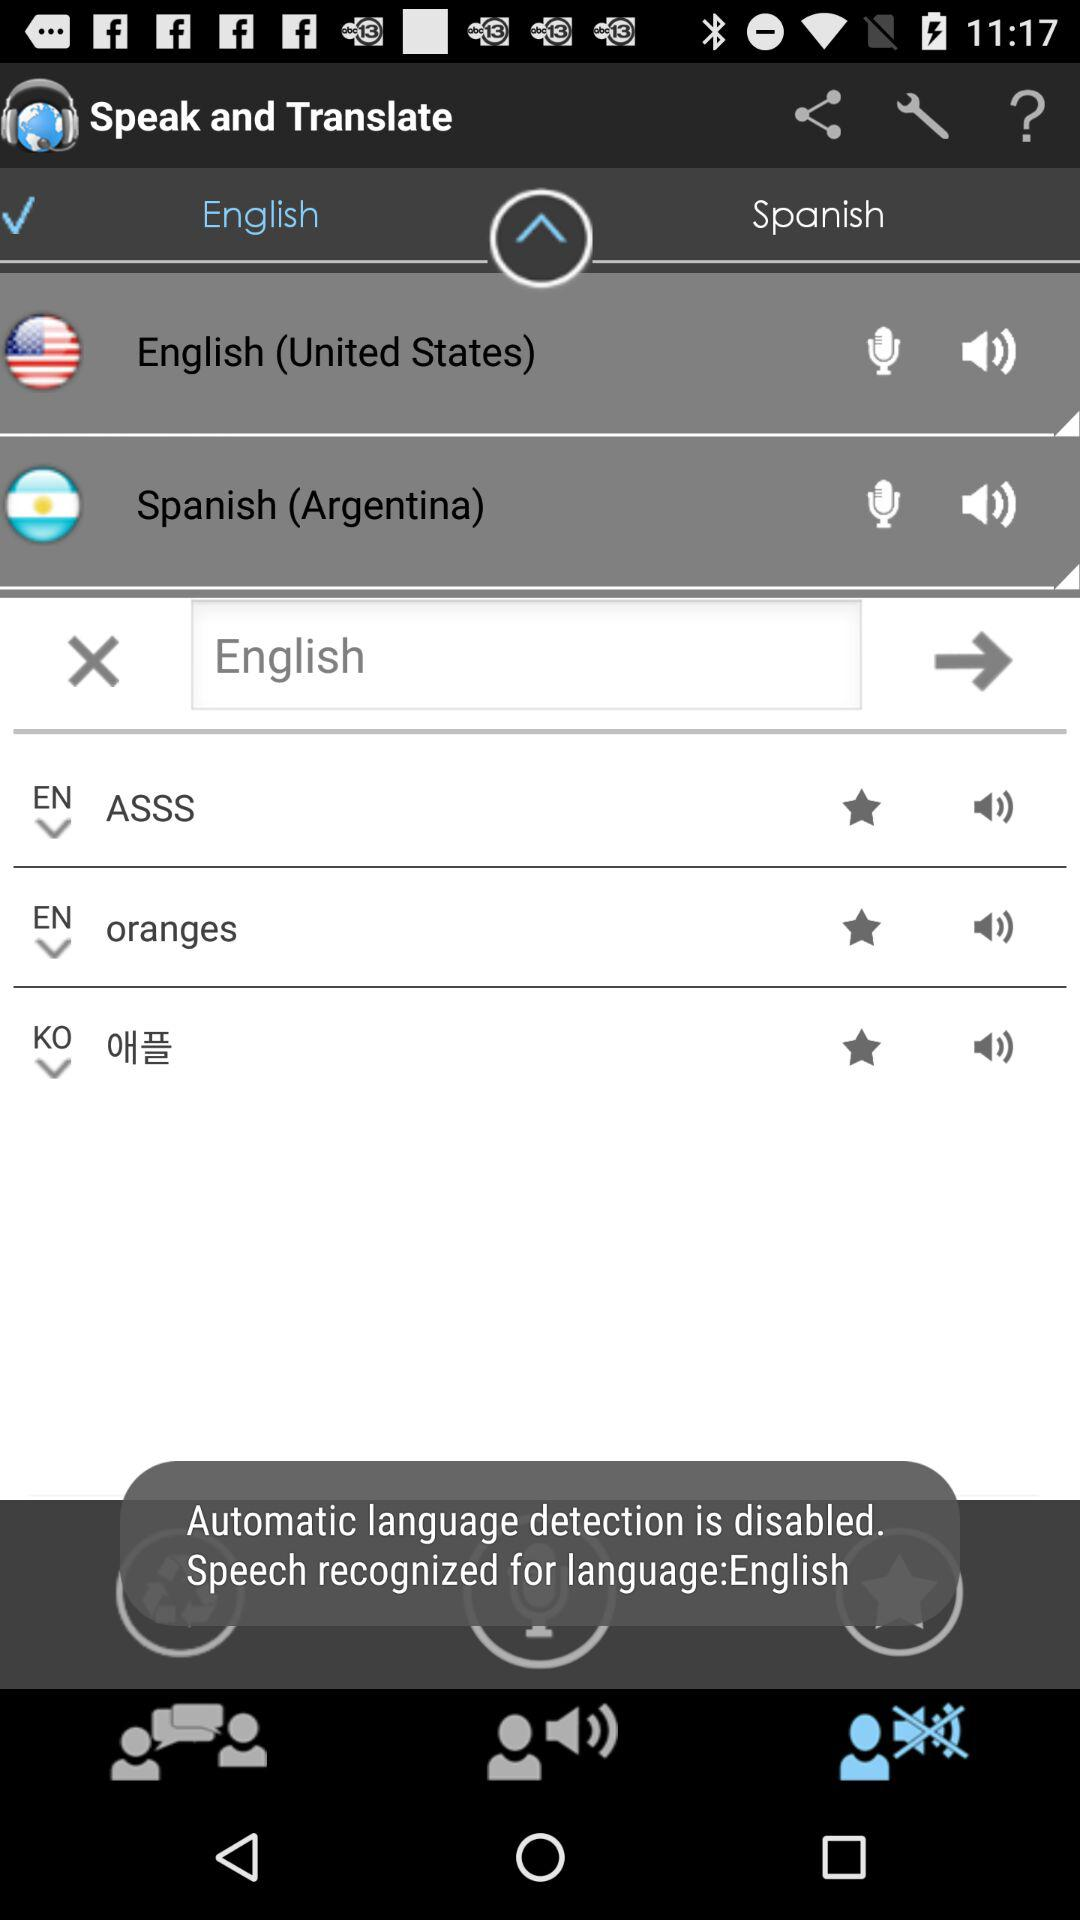Which language has been selected? The language that has been selected is "English". 